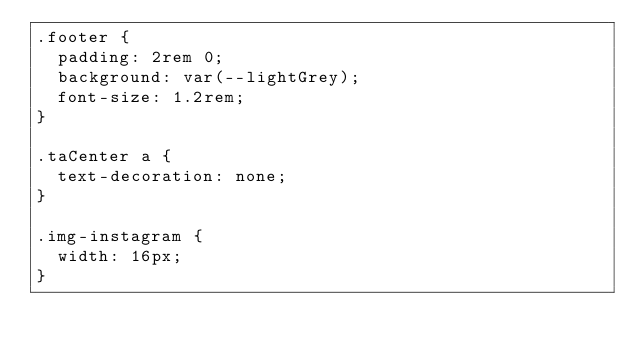<code> <loc_0><loc_0><loc_500><loc_500><_CSS_>.footer {
  padding: 2rem 0;
  background: var(--lightGrey);
  font-size: 1.2rem;
}

.taCenter a {
  text-decoration: none;
}

.img-instagram {
  width: 16px;
}</code> 